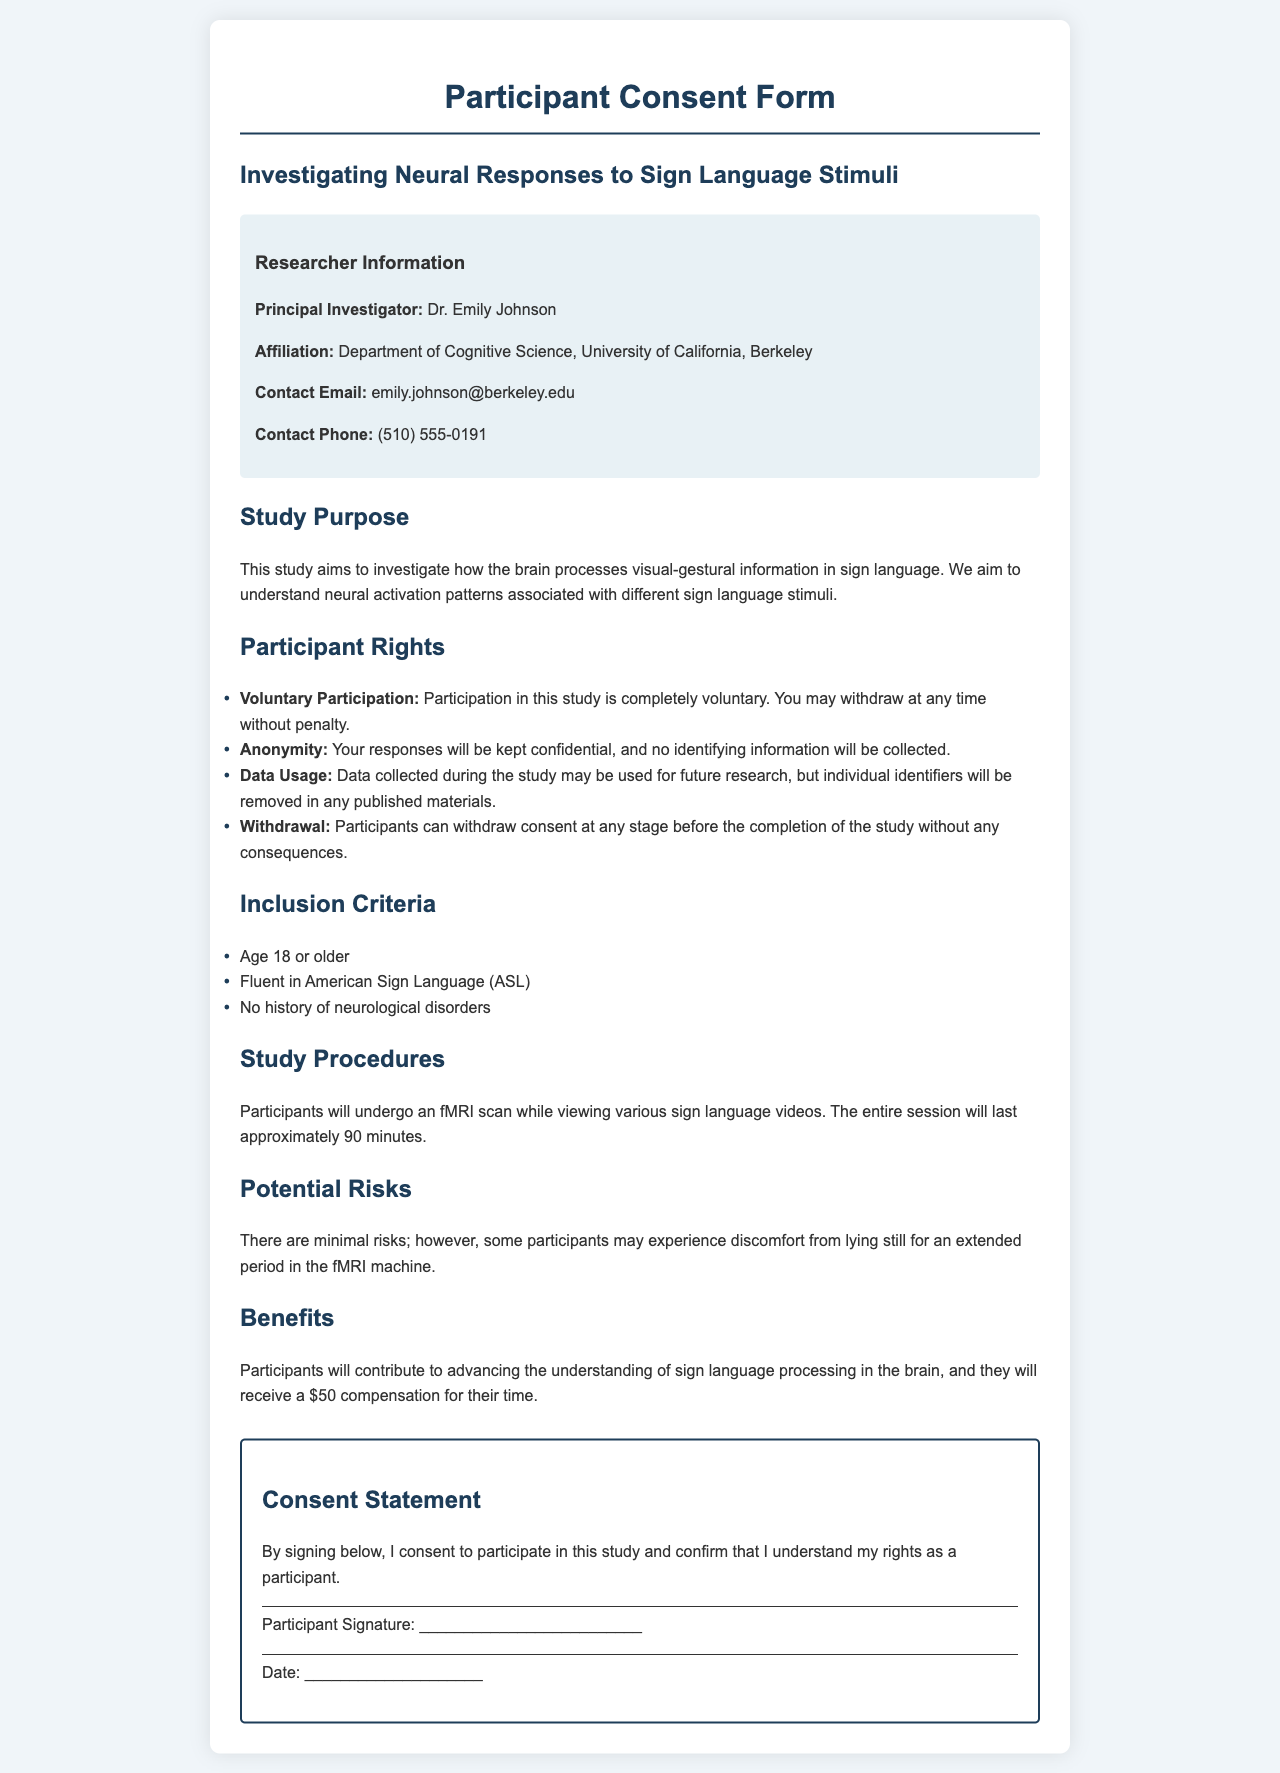What is the title of the study? The title of the study is provided in the document and is "Investigating Neural Responses to Sign Language Stimuli."
Answer: Investigating Neural Responses to Sign Language Stimuli Who is the principal investigator? The name of the principal investigator is mentioned in the researcher information section of the document.
Answer: Dr. Emily Johnson What is the contact email of the principal investigator? The document includes a contact email for the principal investigator, which is part of the researcher information section.
Answer: emily.johnson@berkeley.edu What are the inclusion criteria for participants? The document lists the inclusion criteria in a specific section, which indicates who can participate.
Answer: Age 18 or older, Fluent in American Sign Language (ASL), No history of neurological disorders What compensation will participants receive? The document mentions the compensation provided to participants for their time in the study, found in the benefits section.
Answer: $50 What potential risk is mentioned regarding the fMRI procedure? The document outlines potential risks in the relevant section, focusing on discomfort during the procedure.
Answer: Discomfort from lying still What is the duration of the fMRI session? The duration of the fMRI session is stated in the study procedures section of the document.
Answer: Approximately 90 minutes Can participants withdraw at any time? The document clearly states participant rights regarding withdrawal in a specific section.
Answer: Yes, without penalty 